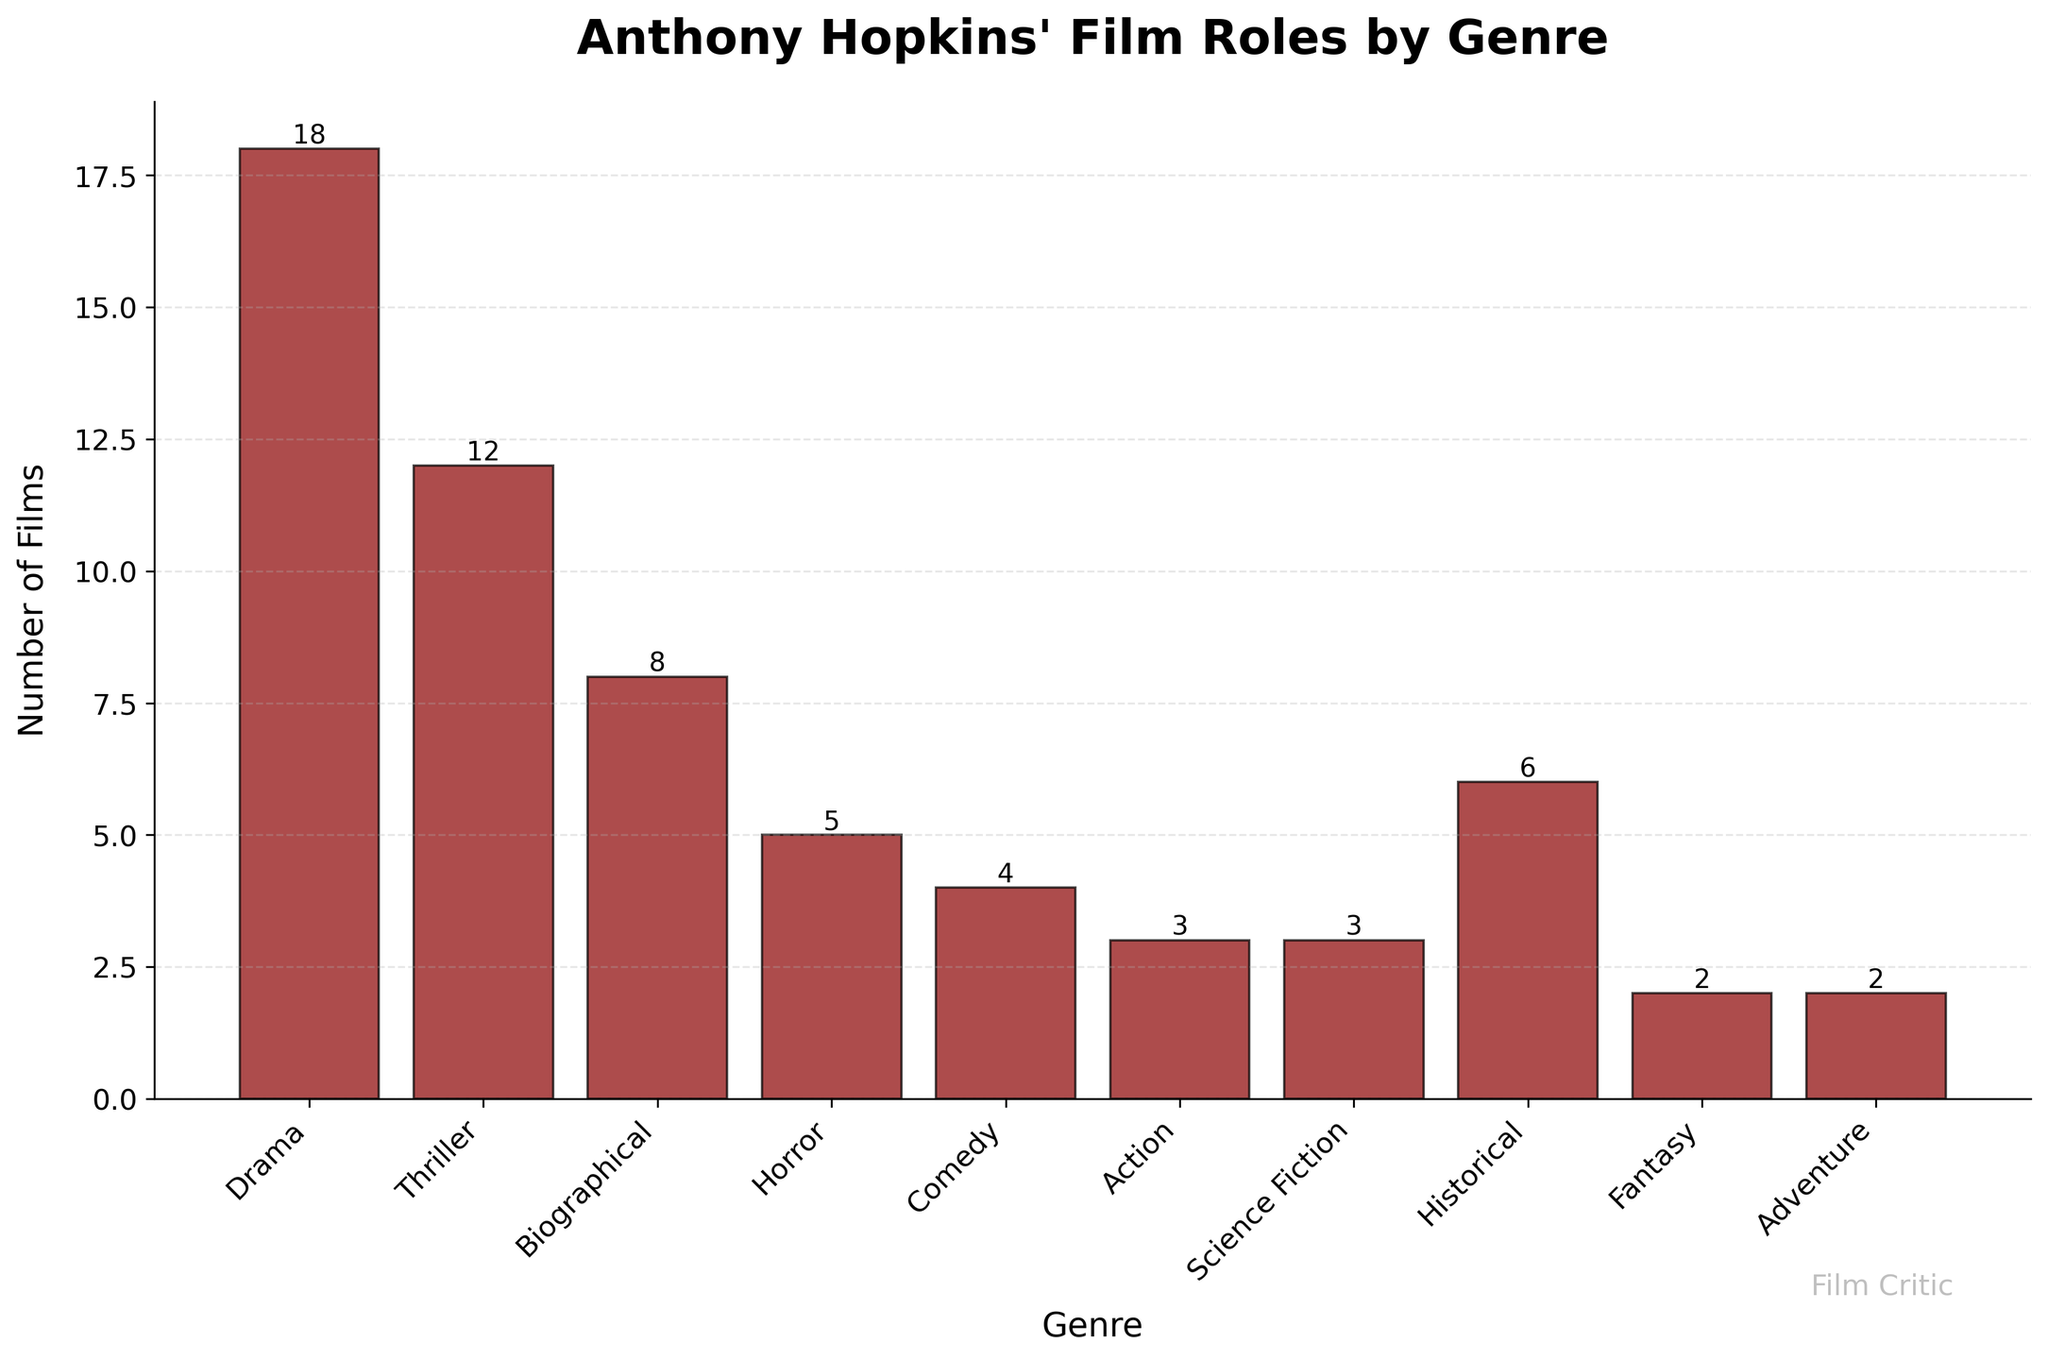How many more Drama films has Anthony Hopkins done compared to Horror films? The bar for Drama films indicates Hopkins has done 18 Drama films, whereas the bar for Horror films indicates 5. The difference is calculated by subtracting 5 from 18.
Answer: 13 Which genre has the second highest number of films? The highest number of films is for Drama with 18 films, and the second highest number is for Thriller with 12 films.
Answer: Thriller What is the total number of films Anthony Hopkins has done in Biographical and Historical genres combined? The visual shows 8 Biographical films and 6 Historical films. Adding these together gives us 14 films.
Answer: 14 Are there more Comedy films or Action films? By comparing the heights of the bars, Comedy is taller with 4 films, whereas Action has 3 films, indicating there are more Comedy films.
Answer: Comedy Which genre has the fewest films, and how many are there? The shortest bars are for Fantasy and Adventure, each with 2 films.
Answer: Fantasy and Adventure, 2 What is the difference between the number of Thriller and Science Fiction films? The bar for Thriller indicates 12 films, and the bar for Science Fiction shows 3 films. The difference is 12 - 3.
Answer: 9 How many films in total are represented in the chart? Summing all the values from the bars: 18 (Drama) + 12 (Thriller) + 8 (Biographical) + 5 (Horror) + 4 (Comedy) + 3 (Action) + 3 (Science Fiction) + 6 (Historical) + 2 (Fantasy) + 2 (Adventure) = 63.
Answer: 63 What is the average number of films per genre? There are 10 genres in total. The total number of films is 63. Dividing the total by the number of genres gives the average: 63 / 10.
Answer: 6.3 Which genre's bar color is darker red compared to others? The color of all bars is the same: dark red.
Answer: All the same 